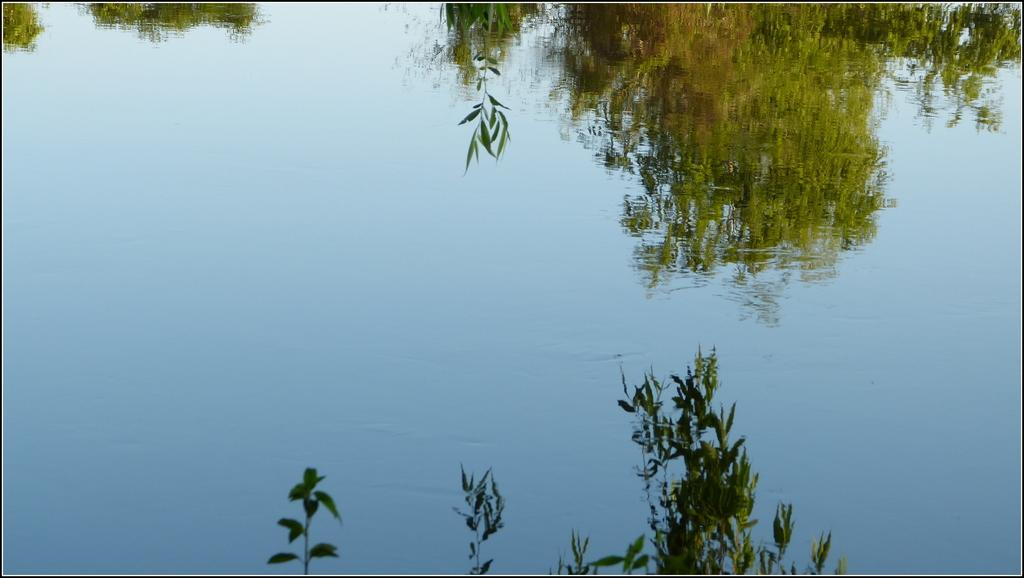What is located at the bottom of the image? There are plants at the bottom of the image. What can be seen in the middle of the image? There are waves in the middle of the image. What is the primary element visible in the image? Water is visible in the image. What can be observed on the surface of the water? Reflections of trees and plants are present on the water. How many friends are visible in the image? There are no friends present in the image; it features plants, waves, and water with reflections. Can you tell me what type of yak is swimming in the water? There is no yak present in the image; it features plants, waves, and water with reflections. 